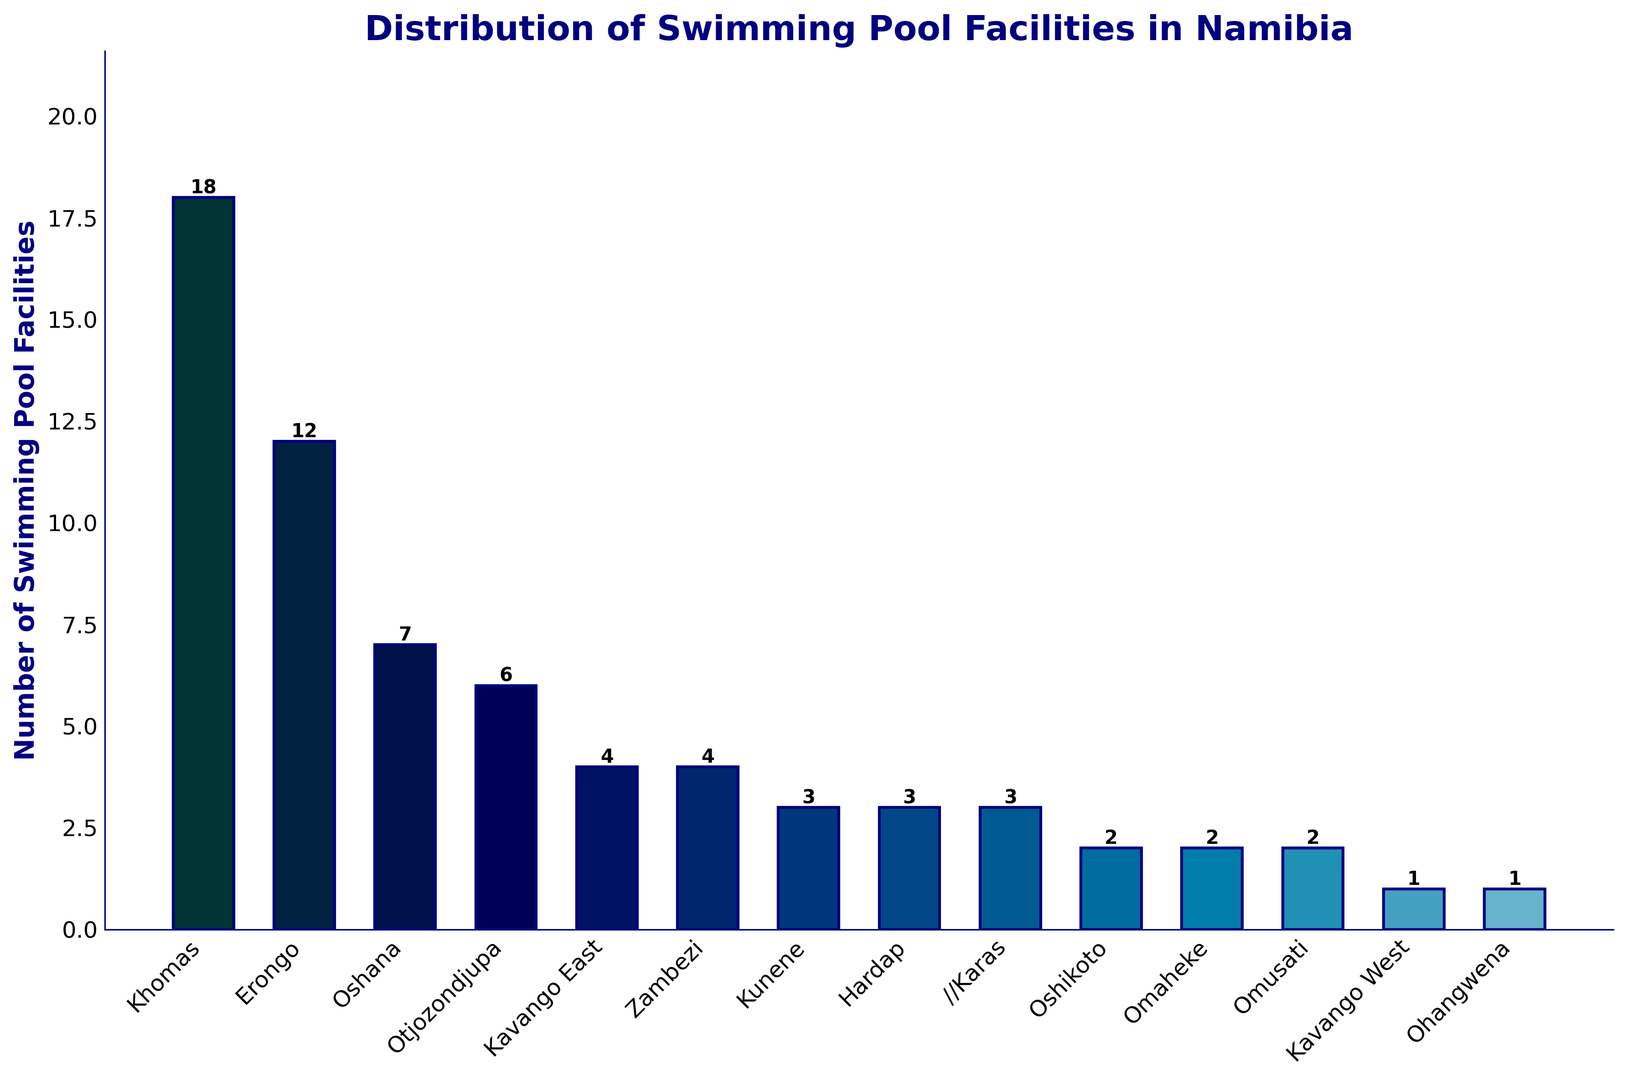Which region has the highest number of swimming pool facilities? The bar for Khomas region is the tallest, indicating it has the highest number of swimming pool facilities. The count displayed on top of the bar for Khomas is 18.
Answer: Khomas How many more swimming pool facilities does Khomas have compared to Erongo? Khomas has 18 facilities and Erongo has 12 facilities. The difference is 18 - 12 = 6.
Answer: 6 What is the average number of swimming pool facilities in the regions with at least 4 facilities? The regions with at least 4 facilities are Khomas (18), Erongo (12), Oshana (7), Otjozondjupa (6), Kavango East (4), and Zambezi (4). The sum of facilities is 18 + 12 + 7 + 6 + 4 + 4 = 51. The number of regions is 6, so the average is 51 / 6 = 8.5.
Answer: 8.5 Which regions have the same number of swimming pool facilities, and how many do they have? The bars for Zambezi, Kavango East, Kunene, Hardap, and //Karas have the same height indicating the same number of facilities. The count displayed is 4 for Zambezi and Kavango East, and 3 for Kunene, Hardap, and //Karas.
Answer: Zambezi and Kavango East: 4, Kunene, Hardap, and //Karas: 3 What is the combined total number of swimming pool facilities in Oshana, Otjozondjupa, and Kavango East regions? Oshana has 7 facilities, Otjozondjupa has 6 facilities, and Kavango East has 4 facilities. The combined total is 7 + 6 + 4 = 17.
Answer: 17 How does the number of swimming pool facilities in Oshikoto compare to Omusati? The height of the bars for Oshikoto and Omusati is the same, and the count shown on top of both bars is 2, indicating they have the same number of facilities.
Answer: Same What is the total number of swimming pool facilities across all regions? Sum up the number of facilities across all regions: 18 (Khomas) + 12 (Erongo) + 7 (Oshana) + 6 (Otjozondjupa) + 4 (Kavango East) + 4 (Zambezi) + 3 (Kunene) + 3 (Hardap) + 3 (//Karas) + 2 (Oshikoto) + 2 (Omaheke) + 2 (Omusati) + 1 (Kavango West) + 1 (Ohangwena) = 68.
Answer: 68 What is the median number of swimming pool facilities among the regions? Arrange the number of facilities in ascending order: 1, 1, 2, 2, 2, 3, 3, 3, 4, 4, 6, 7, 12, 18. The median is the average of the middle two numbers in this list (3 and 4), so (3 + 4) / 2 = 3.5.
Answer: 3.5 